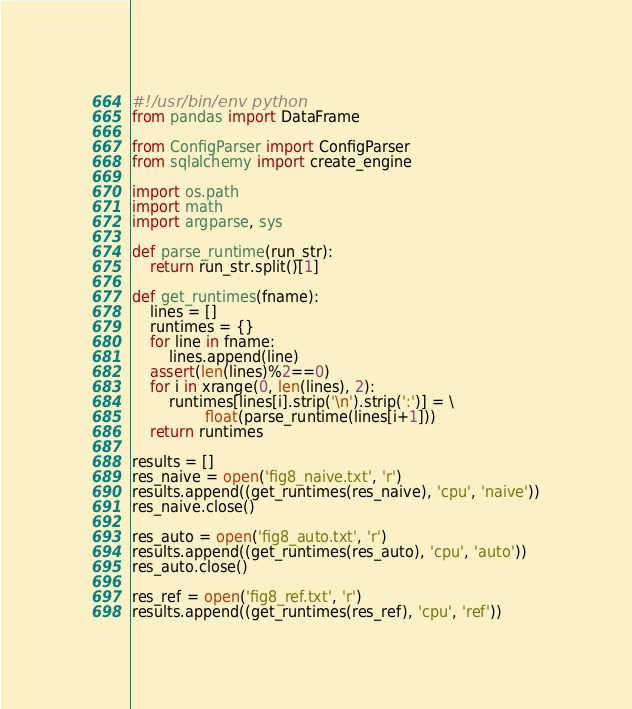Convert code to text. <code><loc_0><loc_0><loc_500><loc_500><_Python_>#!/usr/bin/env python
from pandas import DataFrame

from ConfigParser import ConfigParser
from sqlalchemy import create_engine

import os.path
import math
import argparse, sys

def parse_runtime(run_str):
    return run_str.split()[1]

def get_runtimes(fname):
    lines = []
    runtimes = {}
    for line in fname:
        lines.append(line)
    assert(len(lines)%2==0)
    for i in xrange(0, len(lines), 2):
        runtimes[lines[i].strip('\n').strip(':')] = \
                float(parse_runtime(lines[i+1]))
    return runtimes

results = []
res_naive = open('fig8_naive.txt', 'r')
results.append((get_runtimes(res_naive), 'cpu', 'naive'))
res_naive.close()

res_auto = open('fig8_auto.txt', 'r')
results.append((get_runtimes(res_auto), 'cpu', 'auto'))
res_auto.close()

res_ref = open('fig8_ref.txt', 'r')
results.append((get_runtimes(res_ref), 'cpu', 'ref'))</code> 